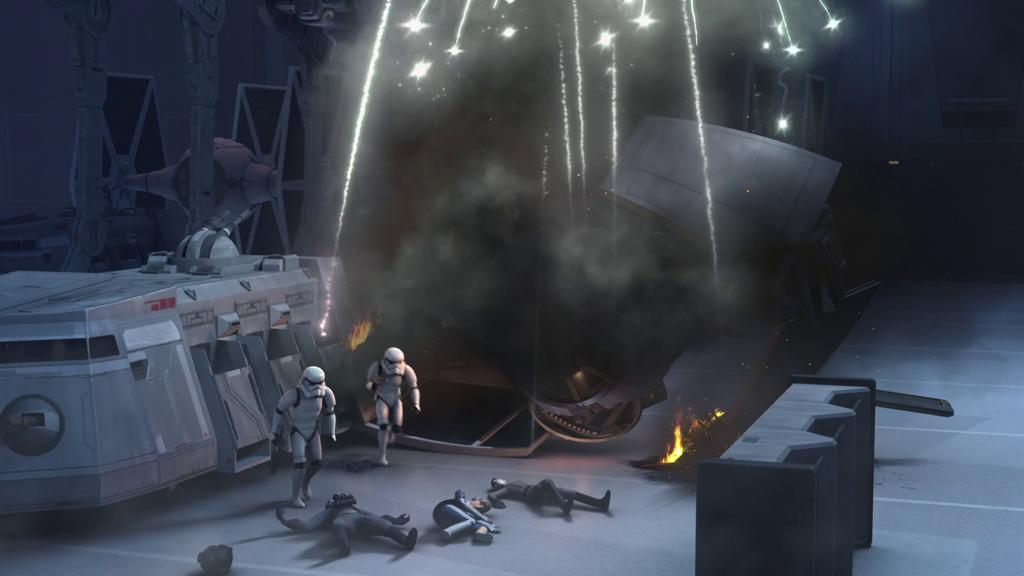What are the people in the image doing? There are three people lying on the floor, and two people walking. What else can be seen in the image besides people? There are machines and objects in the image. Can you describe the presence of fire in the image? Yes, there is fire in the image. What is the financial condition of the people in the image? The provided facts do not give any information about the financial condition of the people in the image. --- Facts: 1. There is a person holding a book. 2. The book has a blue cover. 3. The person is sitting on a chair. 4. There is a table in the image. 5. The table has a lamp on it. Absurd Topics: dance, ocean, animal Conversation: What is the person in the image holding? The person is holding a book. Can you describe the book's appearance? The book has a blue cover. What is the person sitting on? The person is sitting on a chair. What else can be seen in the image? There is a table in the image, and it has a lamp on it. Reasoning: Let's think step by step in order to produce the conversation. We start by identifying the main subject in the image, which is the person holding a book. Then, we describe the book's appearance, mentioning its blue cover. Next, we observe the person's position, noting that they are sitting on a chair. Finally, we describe the table and the lamp on it. Absurd Question/Answer: Can you see any animals in the image? No, there are no animals present in the image. 